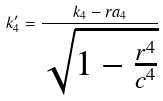Convert formula to latex. <formula><loc_0><loc_0><loc_500><loc_500>k _ { 4 } ^ { \prime } = \frac { k _ { 4 } - r a _ { 4 } } { \sqrt { 1 - \frac { r ^ { 4 } } { c ^ { 4 } } } }</formula> 